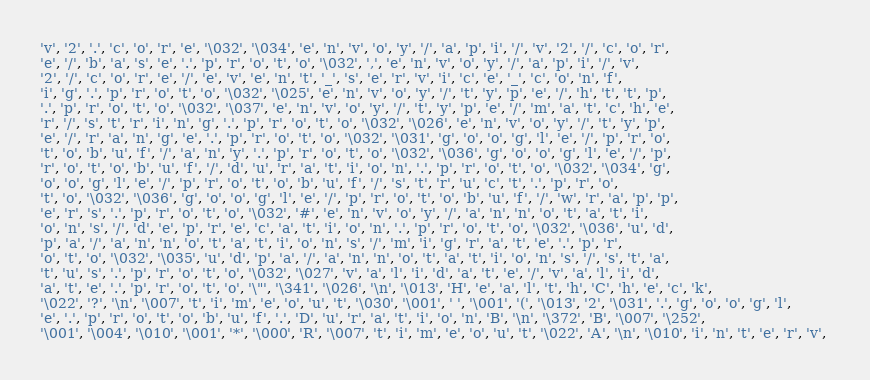<code> <loc_0><loc_0><loc_500><loc_500><_C_>'v', '2', '.', 'c', 'o', 'r', 'e', '\032', '\034', 'e', 'n', 'v', 'o', 'y', '/', 'a', 'p', 'i', '/', 'v', '2', '/', 'c', 'o', 'r', 
'e', '/', 'b', 'a', 's', 'e', '.', 'p', 'r', 'o', 't', 'o', '\032', ',', 'e', 'n', 'v', 'o', 'y', '/', 'a', 'p', 'i', '/', 'v', 
'2', '/', 'c', 'o', 'r', 'e', '/', 'e', 'v', 'e', 'n', 't', '_', 's', 'e', 'r', 'v', 'i', 'c', 'e', '_', 'c', 'o', 'n', 'f', 
'i', 'g', '.', 'p', 'r', 'o', 't', 'o', '\032', '\025', 'e', 'n', 'v', 'o', 'y', '/', 't', 'y', 'p', 'e', '/', 'h', 't', 't', 'p', 
'.', 'p', 'r', 'o', 't', 'o', '\032', '\037', 'e', 'n', 'v', 'o', 'y', '/', 't', 'y', 'p', 'e', '/', 'm', 'a', 't', 'c', 'h', 'e', 
'r', '/', 's', 't', 'r', 'i', 'n', 'g', '.', 'p', 'r', 'o', 't', 'o', '\032', '\026', 'e', 'n', 'v', 'o', 'y', '/', 't', 'y', 'p', 
'e', '/', 'r', 'a', 'n', 'g', 'e', '.', 'p', 'r', 'o', 't', 'o', '\032', '\031', 'g', 'o', 'o', 'g', 'l', 'e', '/', 'p', 'r', 'o', 
't', 'o', 'b', 'u', 'f', '/', 'a', 'n', 'y', '.', 'p', 'r', 'o', 't', 'o', '\032', '\036', 'g', 'o', 'o', 'g', 'l', 'e', '/', 'p', 
'r', 'o', 't', 'o', 'b', 'u', 'f', '/', 'd', 'u', 'r', 'a', 't', 'i', 'o', 'n', '.', 'p', 'r', 'o', 't', 'o', '\032', '\034', 'g', 
'o', 'o', 'g', 'l', 'e', '/', 'p', 'r', 'o', 't', 'o', 'b', 'u', 'f', '/', 's', 't', 'r', 'u', 'c', 't', '.', 'p', 'r', 'o', 
't', 'o', '\032', '\036', 'g', 'o', 'o', 'g', 'l', 'e', '/', 'p', 'r', 'o', 't', 'o', 'b', 'u', 'f', '/', 'w', 'r', 'a', 'p', 'p', 
'e', 'r', 's', '.', 'p', 'r', 'o', 't', 'o', '\032', '#', 'e', 'n', 'v', 'o', 'y', '/', 'a', 'n', 'n', 'o', 't', 'a', 't', 'i', 
'o', 'n', 's', '/', 'd', 'e', 'p', 'r', 'e', 'c', 'a', 't', 'i', 'o', 'n', '.', 'p', 'r', 'o', 't', 'o', '\032', '\036', 'u', 'd', 
'p', 'a', '/', 'a', 'n', 'n', 'o', 't', 'a', 't', 'i', 'o', 'n', 's', '/', 'm', 'i', 'g', 'r', 'a', 't', 'e', '.', 'p', 'r', 
'o', 't', 'o', '\032', '\035', 'u', 'd', 'p', 'a', '/', 'a', 'n', 'n', 'o', 't', 'a', 't', 'i', 'o', 'n', 's', '/', 's', 't', 'a', 
't', 'u', 's', '.', 'p', 'r', 'o', 't', 'o', '\032', '\027', 'v', 'a', 'l', 'i', 'd', 'a', 't', 'e', '/', 'v', 'a', 'l', 'i', 'd', 
'a', 't', 'e', '.', 'p', 'r', 'o', 't', 'o', '\"', '\341', '\026', '\n', '\013', 'H', 'e', 'a', 'l', 't', 'h', 'C', 'h', 'e', 'c', 'k', 
'\022', '?', '\n', '\007', 't', 'i', 'm', 'e', 'o', 'u', 't', '\030', '\001', ' ', '\001', '(', '\013', '2', '\031', '.', 'g', 'o', 'o', 'g', 'l', 
'e', '.', 'p', 'r', 'o', 't', 'o', 'b', 'u', 'f', '.', 'D', 'u', 'r', 'a', 't', 'i', 'o', 'n', 'B', '\n', '\372', 'B', '\007', '\252', 
'\001', '\004', '\010', '\001', '*', '\000', 'R', '\007', 't', 'i', 'm', 'e', 'o', 'u', 't', '\022', 'A', '\n', '\010', 'i', 'n', 't', 'e', 'r', 'v', </code> 